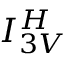<formula> <loc_0><loc_0><loc_500><loc_500>I _ { 3 V } ^ { H }</formula> 